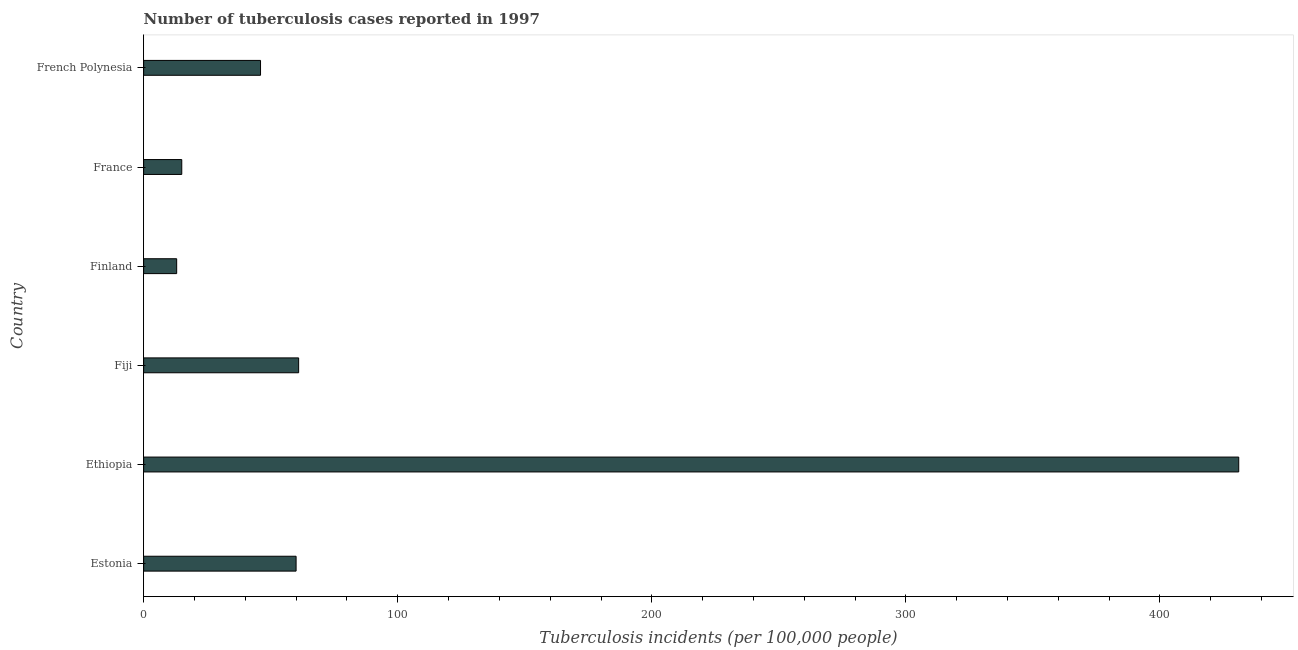What is the title of the graph?
Give a very brief answer. Number of tuberculosis cases reported in 1997. What is the label or title of the X-axis?
Keep it short and to the point. Tuberculosis incidents (per 100,0 people). What is the label or title of the Y-axis?
Give a very brief answer. Country. Across all countries, what is the maximum number of tuberculosis incidents?
Ensure brevity in your answer.  431. In which country was the number of tuberculosis incidents maximum?
Keep it short and to the point. Ethiopia. In which country was the number of tuberculosis incidents minimum?
Provide a short and direct response. Finland. What is the sum of the number of tuberculosis incidents?
Provide a succinct answer. 626. What is the difference between the number of tuberculosis incidents in Ethiopia and Fiji?
Ensure brevity in your answer.  370. What is the average number of tuberculosis incidents per country?
Offer a terse response. 104.33. What is the median number of tuberculosis incidents?
Provide a short and direct response. 53. What is the ratio of the number of tuberculosis incidents in Ethiopia to that in French Polynesia?
Your answer should be very brief. 9.37. Is the difference between the number of tuberculosis incidents in Fiji and France greater than the difference between any two countries?
Offer a very short reply. No. What is the difference between the highest and the second highest number of tuberculosis incidents?
Give a very brief answer. 370. What is the difference between the highest and the lowest number of tuberculosis incidents?
Keep it short and to the point. 418. In how many countries, is the number of tuberculosis incidents greater than the average number of tuberculosis incidents taken over all countries?
Your response must be concise. 1. How many countries are there in the graph?
Provide a succinct answer. 6. Are the values on the major ticks of X-axis written in scientific E-notation?
Give a very brief answer. No. What is the Tuberculosis incidents (per 100,000 people) of Estonia?
Offer a terse response. 60. What is the Tuberculosis incidents (per 100,000 people) in Ethiopia?
Your answer should be compact. 431. What is the difference between the Tuberculosis incidents (per 100,000 people) in Estonia and Ethiopia?
Offer a very short reply. -371. What is the difference between the Tuberculosis incidents (per 100,000 people) in Estonia and France?
Your answer should be compact. 45. What is the difference between the Tuberculosis incidents (per 100,000 people) in Estonia and French Polynesia?
Your response must be concise. 14. What is the difference between the Tuberculosis incidents (per 100,000 people) in Ethiopia and Fiji?
Your response must be concise. 370. What is the difference between the Tuberculosis incidents (per 100,000 people) in Ethiopia and Finland?
Offer a terse response. 418. What is the difference between the Tuberculosis incidents (per 100,000 people) in Ethiopia and France?
Make the answer very short. 416. What is the difference between the Tuberculosis incidents (per 100,000 people) in Ethiopia and French Polynesia?
Your response must be concise. 385. What is the difference between the Tuberculosis incidents (per 100,000 people) in Fiji and France?
Your answer should be very brief. 46. What is the difference between the Tuberculosis incidents (per 100,000 people) in Finland and France?
Provide a short and direct response. -2. What is the difference between the Tuberculosis incidents (per 100,000 people) in Finland and French Polynesia?
Offer a very short reply. -33. What is the difference between the Tuberculosis incidents (per 100,000 people) in France and French Polynesia?
Offer a very short reply. -31. What is the ratio of the Tuberculosis incidents (per 100,000 people) in Estonia to that in Ethiopia?
Your answer should be compact. 0.14. What is the ratio of the Tuberculosis incidents (per 100,000 people) in Estonia to that in Fiji?
Your answer should be compact. 0.98. What is the ratio of the Tuberculosis incidents (per 100,000 people) in Estonia to that in Finland?
Your answer should be compact. 4.62. What is the ratio of the Tuberculosis incidents (per 100,000 people) in Estonia to that in French Polynesia?
Give a very brief answer. 1.3. What is the ratio of the Tuberculosis incidents (per 100,000 people) in Ethiopia to that in Fiji?
Ensure brevity in your answer.  7.07. What is the ratio of the Tuberculosis incidents (per 100,000 people) in Ethiopia to that in Finland?
Your response must be concise. 33.15. What is the ratio of the Tuberculosis incidents (per 100,000 people) in Ethiopia to that in France?
Make the answer very short. 28.73. What is the ratio of the Tuberculosis incidents (per 100,000 people) in Ethiopia to that in French Polynesia?
Your response must be concise. 9.37. What is the ratio of the Tuberculosis incidents (per 100,000 people) in Fiji to that in Finland?
Keep it short and to the point. 4.69. What is the ratio of the Tuberculosis incidents (per 100,000 people) in Fiji to that in France?
Ensure brevity in your answer.  4.07. What is the ratio of the Tuberculosis incidents (per 100,000 people) in Fiji to that in French Polynesia?
Provide a short and direct response. 1.33. What is the ratio of the Tuberculosis incidents (per 100,000 people) in Finland to that in France?
Your response must be concise. 0.87. What is the ratio of the Tuberculosis incidents (per 100,000 people) in Finland to that in French Polynesia?
Offer a very short reply. 0.28. What is the ratio of the Tuberculosis incidents (per 100,000 people) in France to that in French Polynesia?
Make the answer very short. 0.33. 